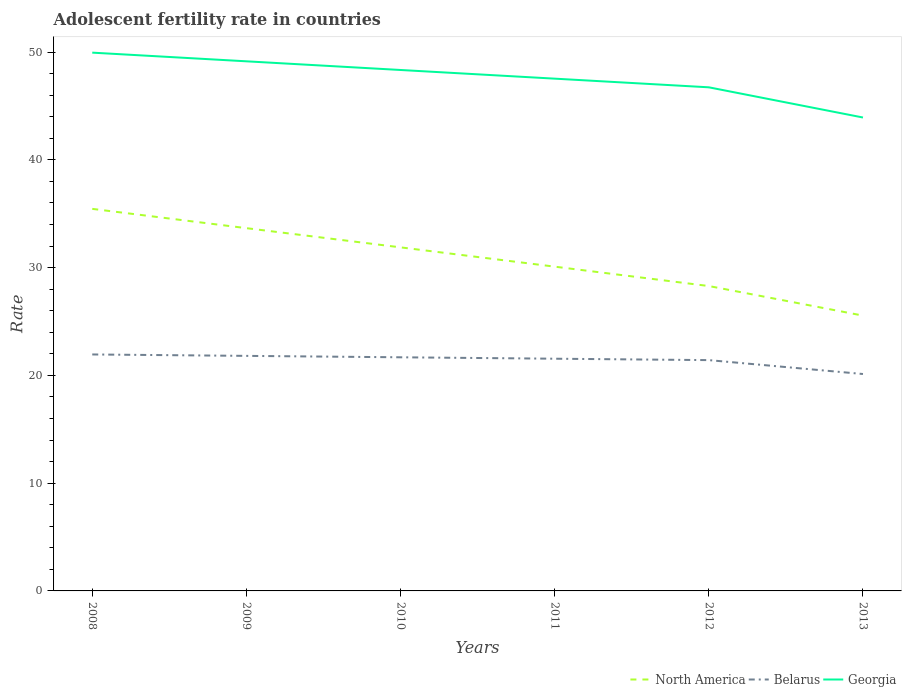How many different coloured lines are there?
Provide a short and direct response. 3. Does the line corresponding to Belarus intersect with the line corresponding to North America?
Provide a succinct answer. No. Is the number of lines equal to the number of legend labels?
Ensure brevity in your answer.  Yes. Across all years, what is the maximum adolescent fertility rate in Georgia?
Offer a terse response. 43.93. In which year was the adolescent fertility rate in North America maximum?
Your answer should be very brief. 2013. What is the total adolescent fertility rate in Belarus in the graph?
Make the answer very short. 0.53. What is the difference between the highest and the second highest adolescent fertility rate in North America?
Your answer should be very brief. 9.91. What is the difference between the highest and the lowest adolescent fertility rate in North America?
Give a very brief answer. 3. How many lines are there?
Your response must be concise. 3. How many years are there in the graph?
Provide a succinct answer. 6. How many legend labels are there?
Your response must be concise. 3. What is the title of the graph?
Your answer should be compact. Adolescent fertility rate in countries. What is the label or title of the X-axis?
Provide a succinct answer. Years. What is the label or title of the Y-axis?
Provide a short and direct response. Rate. What is the Rate of North America in 2008?
Provide a succinct answer. 35.45. What is the Rate in Belarus in 2008?
Provide a succinct answer. 21.94. What is the Rate in Georgia in 2008?
Your answer should be compact. 49.95. What is the Rate of North America in 2009?
Provide a short and direct response. 33.66. What is the Rate in Belarus in 2009?
Give a very brief answer. 21.81. What is the Rate in Georgia in 2009?
Keep it short and to the point. 49.15. What is the Rate of North America in 2010?
Make the answer very short. 31.88. What is the Rate in Belarus in 2010?
Give a very brief answer. 21.68. What is the Rate of Georgia in 2010?
Your answer should be compact. 48.34. What is the Rate in North America in 2011?
Your answer should be compact. 30.09. What is the Rate of Belarus in 2011?
Offer a very short reply. 21.55. What is the Rate of Georgia in 2011?
Offer a very short reply. 47.54. What is the Rate in North America in 2012?
Give a very brief answer. 28.29. What is the Rate of Belarus in 2012?
Give a very brief answer. 21.42. What is the Rate of Georgia in 2012?
Ensure brevity in your answer.  46.73. What is the Rate of North America in 2013?
Provide a short and direct response. 25.55. What is the Rate in Belarus in 2013?
Your answer should be very brief. 20.13. What is the Rate in Georgia in 2013?
Keep it short and to the point. 43.93. Across all years, what is the maximum Rate in North America?
Your answer should be compact. 35.45. Across all years, what is the maximum Rate of Belarus?
Your response must be concise. 21.94. Across all years, what is the maximum Rate in Georgia?
Offer a terse response. 49.95. Across all years, what is the minimum Rate of North America?
Provide a short and direct response. 25.55. Across all years, what is the minimum Rate in Belarus?
Offer a very short reply. 20.13. Across all years, what is the minimum Rate of Georgia?
Offer a very short reply. 43.93. What is the total Rate of North America in the graph?
Offer a terse response. 184.94. What is the total Rate of Belarus in the graph?
Make the answer very short. 128.53. What is the total Rate of Georgia in the graph?
Keep it short and to the point. 285.65. What is the difference between the Rate of North America in 2008 and that in 2009?
Offer a very short reply. 1.79. What is the difference between the Rate in Belarus in 2008 and that in 2009?
Ensure brevity in your answer.  0.13. What is the difference between the Rate in Georgia in 2008 and that in 2009?
Provide a short and direct response. 0.8. What is the difference between the Rate in North America in 2008 and that in 2010?
Give a very brief answer. 3.57. What is the difference between the Rate in Belarus in 2008 and that in 2010?
Ensure brevity in your answer.  0.26. What is the difference between the Rate of Georgia in 2008 and that in 2010?
Your response must be concise. 1.61. What is the difference between the Rate of North America in 2008 and that in 2011?
Your answer should be compact. 5.36. What is the difference between the Rate in Belarus in 2008 and that in 2011?
Offer a very short reply. 0.39. What is the difference between the Rate of Georgia in 2008 and that in 2011?
Your response must be concise. 2.41. What is the difference between the Rate of North America in 2008 and that in 2012?
Provide a succinct answer. 7.16. What is the difference between the Rate of Belarus in 2008 and that in 2012?
Keep it short and to the point. 0.53. What is the difference between the Rate in Georgia in 2008 and that in 2012?
Your answer should be very brief. 3.22. What is the difference between the Rate of North America in 2008 and that in 2013?
Offer a very short reply. 9.91. What is the difference between the Rate in Belarus in 2008 and that in 2013?
Ensure brevity in your answer.  1.81. What is the difference between the Rate in Georgia in 2008 and that in 2013?
Provide a short and direct response. 6.02. What is the difference between the Rate of North America in 2009 and that in 2010?
Provide a short and direct response. 1.78. What is the difference between the Rate of Belarus in 2009 and that in 2010?
Your response must be concise. 0.13. What is the difference between the Rate of Georgia in 2009 and that in 2010?
Ensure brevity in your answer.  0.8. What is the difference between the Rate in North America in 2009 and that in 2011?
Keep it short and to the point. 3.57. What is the difference between the Rate of Belarus in 2009 and that in 2011?
Provide a short and direct response. 0.26. What is the difference between the Rate of Georgia in 2009 and that in 2011?
Offer a terse response. 1.61. What is the difference between the Rate in North America in 2009 and that in 2012?
Keep it short and to the point. 5.37. What is the difference between the Rate in Belarus in 2009 and that in 2012?
Ensure brevity in your answer.  0.39. What is the difference between the Rate in Georgia in 2009 and that in 2012?
Provide a succinct answer. 2.41. What is the difference between the Rate of North America in 2009 and that in 2013?
Keep it short and to the point. 8.11. What is the difference between the Rate of Belarus in 2009 and that in 2013?
Provide a succinct answer. 1.68. What is the difference between the Rate in Georgia in 2009 and that in 2013?
Make the answer very short. 5.21. What is the difference between the Rate in North America in 2010 and that in 2011?
Your response must be concise. 1.79. What is the difference between the Rate in Belarus in 2010 and that in 2011?
Keep it short and to the point. 0.13. What is the difference between the Rate of Georgia in 2010 and that in 2011?
Keep it short and to the point. 0.8. What is the difference between the Rate of North America in 2010 and that in 2012?
Offer a very short reply. 3.59. What is the difference between the Rate of Belarus in 2010 and that in 2012?
Make the answer very short. 0.26. What is the difference between the Rate in Georgia in 2010 and that in 2012?
Offer a terse response. 1.61. What is the difference between the Rate in North America in 2010 and that in 2013?
Make the answer very short. 6.33. What is the difference between the Rate in Belarus in 2010 and that in 2013?
Your answer should be compact. 1.55. What is the difference between the Rate in Georgia in 2010 and that in 2013?
Your answer should be very brief. 4.41. What is the difference between the Rate of North America in 2011 and that in 2012?
Ensure brevity in your answer.  1.8. What is the difference between the Rate of Belarus in 2011 and that in 2012?
Your answer should be very brief. 0.13. What is the difference between the Rate in Georgia in 2011 and that in 2012?
Provide a succinct answer. 0.8. What is the difference between the Rate in North America in 2011 and that in 2013?
Give a very brief answer. 4.54. What is the difference between the Rate of Belarus in 2011 and that in 2013?
Keep it short and to the point. 1.42. What is the difference between the Rate of Georgia in 2011 and that in 2013?
Offer a very short reply. 3.61. What is the difference between the Rate in North America in 2012 and that in 2013?
Your answer should be very brief. 2.74. What is the difference between the Rate in Belarus in 2012 and that in 2013?
Your answer should be compact. 1.29. What is the difference between the Rate in Georgia in 2012 and that in 2013?
Provide a short and direct response. 2.8. What is the difference between the Rate of North America in 2008 and the Rate of Belarus in 2009?
Ensure brevity in your answer.  13.64. What is the difference between the Rate in North America in 2008 and the Rate in Georgia in 2009?
Provide a succinct answer. -13.69. What is the difference between the Rate of Belarus in 2008 and the Rate of Georgia in 2009?
Offer a very short reply. -27.2. What is the difference between the Rate in North America in 2008 and the Rate in Belarus in 2010?
Ensure brevity in your answer.  13.77. What is the difference between the Rate in North America in 2008 and the Rate in Georgia in 2010?
Keep it short and to the point. -12.89. What is the difference between the Rate of Belarus in 2008 and the Rate of Georgia in 2010?
Provide a short and direct response. -26.4. What is the difference between the Rate of North America in 2008 and the Rate of Belarus in 2011?
Make the answer very short. 13.91. What is the difference between the Rate of North America in 2008 and the Rate of Georgia in 2011?
Provide a succinct answer. -12.08. What is the difference between the Rate in Belarus in 2008 and the Rate in Georgia in 2011?
Give a very brief answer. -25.59. What is the difference between the Rate in North America in 2008 and the Rate in Belarus in 2012?
Give a very brief answer. 14.04. What is the difference between the Rate of North America in 2008 and the Rate of Georgia in 2012?
Offer a very short reply. -11.28. What is the difference between the Rate of Belarus in 2008 and the Rate of Georgia in 2012?
Ensure brevity in your answer.  -24.79. What is the difference between the Rate of North America in 2008 and the Rate of Belarus in 2013?
Give a very brief answer. 15.33. What is the difference between the Rate in North America in 2008 and the Rate in Georgia in 2013?
Give a very brief answer. -8.48. What is the difference between the Rate of Belarus in 2008 and the Rate of Georgia in 2013?
Your response must be concise. -21.99. What is the difference between the Rate in North America in 2009 and the Rate in Belarus in 2010?
Offer a very short reply. 11.98. What is the difference between the Rate of North America in 2009 and the Rate of Georgia in 2010?
Offer a very short reply. -14.68. What is the difference between the Rate in Belarus in 2009 and the Rate in Georgia in 2010?
Your answer should be very brief. -26.53. What is the difference between the Rate in North America in 2009 and the Rate in Belarus in 2011?
Offer a very short reply. 12.11. What is the difference between the Rate in North America in 2009 and the Rate in Georgia in 2011?
Make the answer very short. -13.87. What is the difference between the Rate in Belarus in 2009 and the Rate in Georgia in 2011?
Your response must be concise. -25.73. What is the difference between the Rate of North America in 2009 and the Rate of Belarus in 2012?
Your response must be concise. 12.25. What is the difference between the Rate in North America in 2009 and the Rate in Georgia in 2012?
Keep it short and to the point. -13.07. What is the difference between the Rate of Belarus in 2009 and the Rate of Georgia in 2012?
Your answer should be very brief. -24.92. What is the difference between the Rate in North America in 2009 and the Rate in Belarus in 2013?
Your answer should be very brief. 13.53. What is the difference between the Rate of North America in 2009 and the Rate of Georgia in 2013?
Keep it short and to the point. -10.27. What is the difference between the Rate in Belarus in 2009 and the Rate in Georgia in 2013?
Provide a short and direct response. -22.12. What is the difference between the Rate in North America in 2010 and the Rate in Belarus in 2011?
Your answer should be very brief. 10.33. What is the difference between the Rate in North America in 2010 and the Rate in Georgia in 2011?
Offer a terse response. -15.66. What is the difference between the Rate of Belarus in 2010 and the Rate of Georgia in 2011?
Keep it short and to the point. -25.86. What is the difference between the Rate in North America in 2010 and the Rate in Belarus in 2012?
Give a very brief answer. 10.46. What is the difference between the Rate of North America in 2010 and the Rate of Georgia in 2012?
Make the answer very short. -14.85. What is the difference between the Rate of Belarus in 2010 and the Rate of Georgia in 2012?
Provide a succinct answer. -25.05. What is the difference between the Rate in North America in 2010 and the Rate in Belarus in 2013?
Ensure brevity in your answer.  11.75. What is the difference between the Rate in North America in 2010 and the Rate in Georgia in 2013?
Your answer should be compact. -12.05. What is the difference between the Rate in Belarus in 2010 and the Rate in Georgia in 2013?
Provide a short and direct response. -22.25. What is the difference between the Rate in North America in 2011 and the Rate in Belarus in 2012?
Your answer should be compact. 8.67. What is the difference between the Rate in North America in 2011 and the Rate in Georgia in 2012?
Offer a terse response. -16.64. What is the difference between the Rate of Belarus in 2011 and the Rate of Georgia in 2012?
Offer a very short reply. -25.18. What is the difference between the Rate in North America in 2011 and the Rate in Belarus in 2013?
Give a very brief answer. 9.96. What is the difference between the Rate in North America in 2011 and the Rate in Georgia in 2013?
Offer a terse response. -13.84. What is the difference between the Rate in Belarus in 2011 and the Rate in Georgia in 2013?
Your answer should be very brief. -22.38. What is the difference between the Rate of North America in 2012 and the Rate of Belarus in 2013?
Your response must be concise. 8.16. What is the difference between the Rate in North America in 2012 and the Rate in Georgia in 2013?
Offer a very short reply. -15.64. What is the difference between the Rate of Belarus in 2012 and the Rate of Georgia in 2013?
Provide a short and direct response. -22.51. What is the average Rate of North America per year?
Your answer should be very brief. 30.82. What is the average Rate in Belarus per year?
Provide a succinct answer. 21.42. What is the average Rate of Georgia per year?
Keep it short and to the point. 47.61. In the year 2008, what is the difference between the Rate of North America and Rate of Belarus?
Provide a succinct answer. 13.51. In the year 2008, what is the difference between the Rate of North America and Rate of Georgia?
Your answer should be very brief. -14.5. In the year 2008, what is the difference between the Rate in Belarus and Rate in Georgia?
Make the answer very short. -28.01. In the year 2009, what is the difference between the Rate of North America and Rate of Belarus?
Ensure brevity in your answer.  11.85. In the year 2009, what is the difference between the Rate of North America and Rate of Georgia?
Provide a short and direct response. -15.48. In the year 2009, what is the difference between the Rate of Belarus and Rate of Georgia?
Offer a very short reply. -27.34. In the year 2010, what is the difference between the Rate of North America and Rate of Belarus?
Your answer should be compact. 10.2. In the year 2010, what is the difference between the Rate in North America and Rate in Georgia?
Your answer should be compact. -16.46. In the year 2010, what is the difference between the Rate of Belarus and Rate of Georgia?
Provide a succinct answer. -26.66. In the year 2011, what is the difference between the Rate of North America and Rate of Belarus?
Ensure brevity in your answer.  8.54. In the year 2011, what is the difference between the Rate of North America and Rate of Georgia?
Your response must be concise. -17.45. In the year 2011, what is the difference between the Rate in Belarus and Rate in Georgia?
Your answer should be compact. -25.99. In the year 2012, what is the difference between the Rate of North America and Rate of Belarus?
Offer a terse response. 6.88. In the year 2012, what is the difference between the Rate in North America and Rate in Georgia?
Offer a terse response. -18.44. In the year 2012, what is the difference between the Rate of Belarus and Rate of Georgia?
Offer a terse response. -25.32. In the year 2013, what is the difference between the Rate of North America and Rate of Belarus?
Offer a very short reply. 5.42. In the year 2013, what is the difference between the Rate of North America and Rate of Georgia?
Ensure brevity in your answer.  -18.38. In the year 2013, what is the difference between the Rate of Belarus and Rate of Georgia?
Ensure brevity in your answer.  -23.8. What is the ratio of the Rate in North America in 2008 to that in 2009?
Offer a terse response. 1.05. What is the ratio of the Rate of Belarus in 2008 to that in 2009?
Offer a terse response. 1.01. What is the ratio of the Rate of Georgia in 2008 to that in 2009?
Make the answer very short. 1.02. What is the ratio of the Rate in North America in 2008 to that in 2010?
Keep it short and to the point. 1.11. What is the ratio of the Rate in Belarus in 2008 to that in 2010?
Offer a terse response. 1.01. What is the ratio of the Rate in North America in 2008 to that in 2011?
Your answer should be compact. 1.18. What is the ratio of the Rate of Belarus in 2008 to that in 2011?
Provide a short and direct response. 1.02. What is the ratio of the Rate in Georgia in 2008 to that in 2011?
Your response must be concise. 1.05. What is the ratio of the Rate of North America in 2008 to that in 2012?
Your answer should be very brief. 1.25. What is the ratio of the Rate in Belarus in 2008 to that in 2012?
Your response must be concise. 1.02. What is the ratio of the Rate of Georgia in 2008 to that in 2012?
Offer a very short reply. 1.07. What is the ratio of the Rate in North America in 2008 to that in 2013?
Offer a terse response. 1.39. What is the ratio of the Rate in Belarus in 2008 to that in 2013?
Your answer should be compact. 1.09. What is the ratio of the Rate of Georgia in 2008 to that in 2013?
Offer a very short reply. 1.14. What is the ratio of the Rate in North America in 2009 to that in 2010?
Your answer should be very brief. 1.06. What is the ratio of the Rate of Georgia in 2009 to that in 2010?
Offer a terse response. 1.02. What is the ratio of the Rate in North America in 2009 to that in 2011?
Your response must be concise. 1.12. What is the ratio of the Rate in Belarus in 2009 to that in 2011?
Your answer should be very brief. 1.01. What is the ratio of the Rate of Georgia in 2009 to that in 2011?
Offer a very short reply. 1.03. What is the ratio of the Rate in North America in 2009 to that in 2012?
Your answer should be very brief. 1.19. What is the ratio of the Rate of Belarus in 2009 to that in 2012?
Provide a succinct answer. 1.02. What is the ratio of the Rate in Georgia in 2009 to that in 2012?
Give a very brief answer. 1.05. What is the ratio of the Rate in North America in 2009 to that in 2013?
Keep it short and to the point. 1.32. What is the ratio of the Rate of Belarus in 2009 to that in 2013?
Provide a short and direct response. 1.08. What is the ratio of the Rate in Georgia in 2009 to that in 2013?
Your answer should be very brief. 1.12. What is the ratio of the Rate in North America in 2010 to that in 2011?
Your answer should be compact. 1.06. What is the ratio of the Rate in Georgia in 2010 to that in 2011?
Give a very brief answer. 1.02. What is the ratio of the Rate in North America in 2010 to that in 2012?
Offer a very short reply. 1.13. What is the ratio of the Rate of Belarus in 2010 to that in 2012?
Keep it short and to the point. 1.01. What is the ratio of the Rate of Georgia in 2010 to that in 2012?
Give a very brief answer. 1.03. What is the ratio of the Rate in North America in 2010 to that in 2013?
Your answer should be compact. 1.25. What is the ratio of the Rate in Belarus in 2010 to that in 2013?
Offer a terse response. 1.08. What is the ratio of the Rate of Georgia in 2010 to that in 2013?
Offer a terse response. 1.1. What is the ratio of the Rate in North America in 2011 to that in 2012?
Your answer should be compact. 1.06. What is the ratio of the Rate of Georgia in 2011 to that in 2012?
Offer a terse response. 1.02. What is the ratio of the Rate in North America in 2011 to that in 2013?
Offer a terse response. 1.18. What is the ratio of the Rate of Belarus in 2011 to that in 2013?
Give a very brief answer. 1.07. What is the ratio of the Rate in Georgia in 2011 to that in 2013?
Your answer should be compact. 1.08. What is the ratio of the Rate of North America in 2012 to that in 2013?
Keep it short and to the point. 1.11. What is the ratio of the Rate in Belarus in 2012 to that in 2013?
Ensure brevity in your answer.  1.06. What is the ratio of the Rate in Georgia in 2012 to that in 2013?
Make the answer very short. 1.06. What is the difference between the highest and the second highest Rate in North America?
Your response must be concise. 1.79. What is the difference between the highest and the second highest Rate in Belarus?
Your answer should be compact. 0.13. What is the difference between the highest and the second highest Rate in Georgia?
Make the answer very short. 0.8. What is the difference between the highest and the lowest Rate in North America?
Give a very brief answer. 9.91. What is the difference between the highest and the lowest Rate of Belarus?
Your answer should be compact. 1.81. What is the difference between the highest and the lowest Rate of Georgia?
Provide a short and direct response. 6.02. 